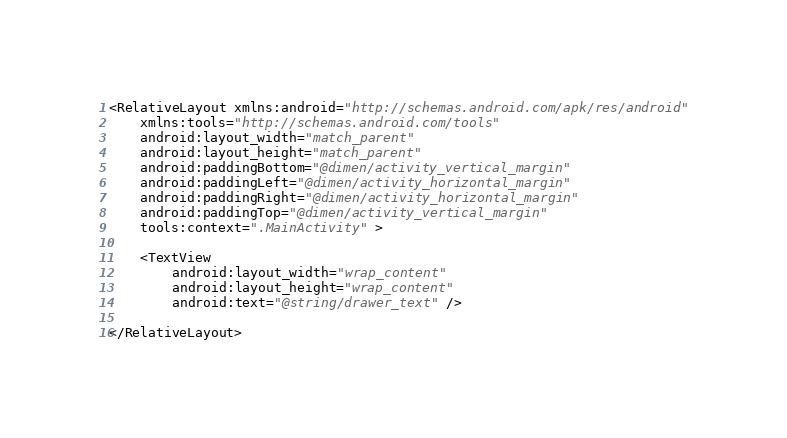Convert code to text. <code><loc_0><loc_0><loc_500><loc_500><_XML_><RelativeLayout xmlns:android="http://schemas.android.com/apk/res/android"
    xmlns:tools="http://schemas.android.com/tools"
    android:layout_width="match_parent"
    android:layout_height="match_parent"
    android:paddingBottom="@dimen/activity_vertical_margin"
    android:paddingLeft="@dimen/activity_horizontal_margin"
    android:paddingRight="@dimen/activity_horizontal_margin"
    android:paddingTop="@dimen/activity_vertical_margin"
    tools:context=".MainActivity" >

    <TextView
        android:layout_width="wrap_content"
        android:layout_height="wrap_content"
        android:text="@string/drawer_text" />

</RelativeLayout></code> 